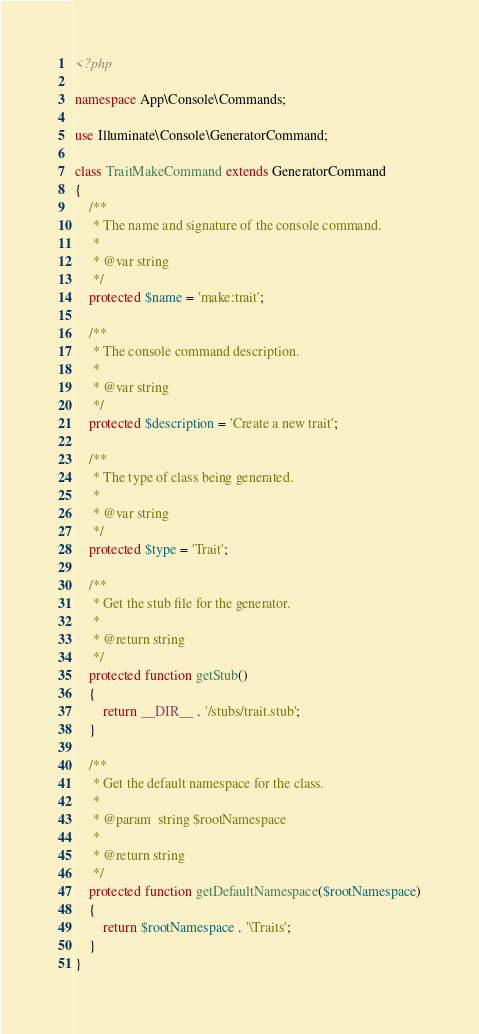<code> <loc_0><loc_0><loc_500><loc_500><_PHP_><?php

namespace App\Console\Commands;

use Illuminate\Console\GeneratorCommand;

class TraitMakeCommand extends GeneratorCommand
{
    /**
     * The name and signature of the console command.
     *
     * @var string
     */
    protected $name = 'make:trait';

    /**
     * The console command description.
     *
     * @var string
     */
    protected $description = 'Create a new trait';

    /**
     * The type of class being generated.
     *
     * @var string
     */
    protected $type = 'Trait';

    /**
     * Get the stub file for the generator.
     *
     * @return string
     */
    protected function getStub()
    {
        return __DIR__ . '/stubs/trait.stub';
    }

    /**
     * Get the default namespace for the class.
     *
     * @param  string $rootNamespace
     *
     * @return string
     */
    protected function getDefaultNamespace($rootNamespace)
    {
        return $rootNamespace . '\Traits';
    }
}
</code> 